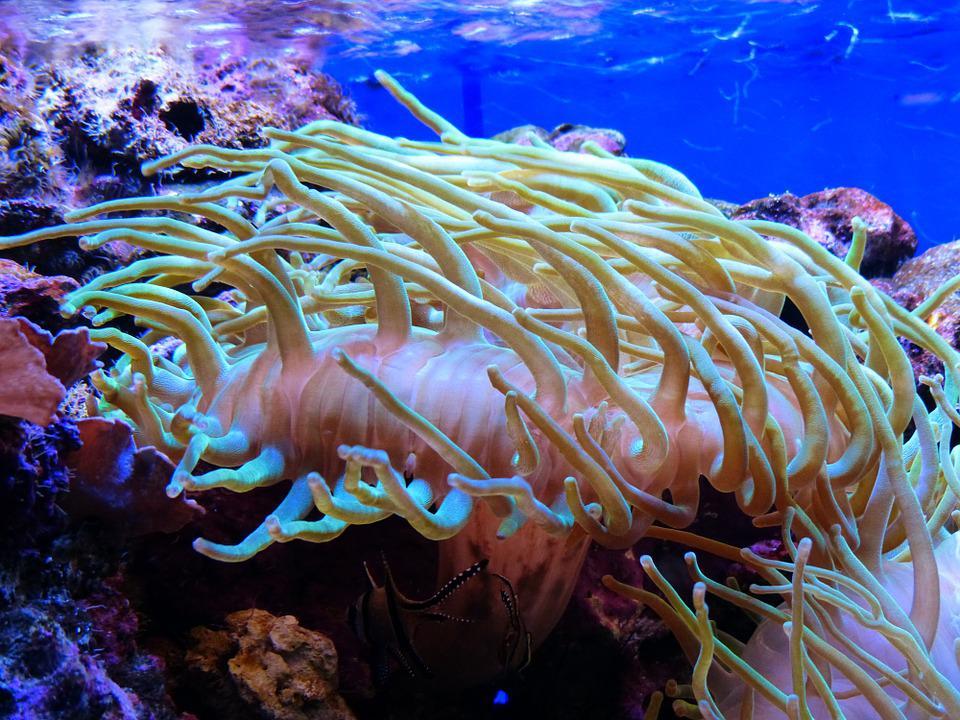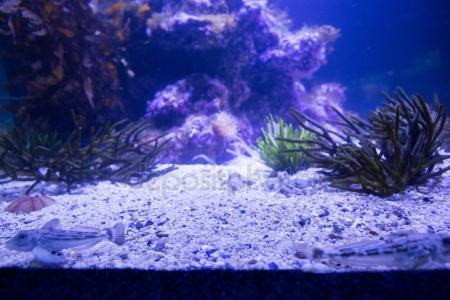The first image is the image on the left, the second image is the image on the right. Assess this claim about the two images: "There are clown fish near the sea anemone.". Correct or not? Answer yes or no. No. The first image is the image on the left, the second image is the image on the right. Examine the images to the left and right. Is the description "There are at least two fishes in the pair of images." accurate? Answer yes or no. No. 